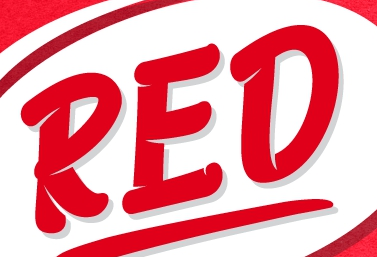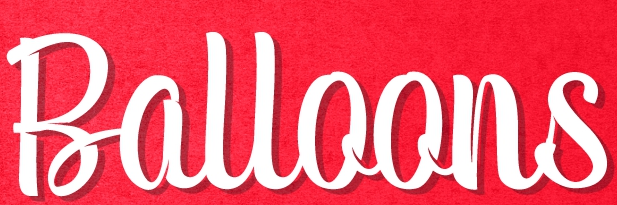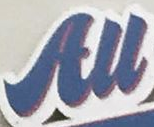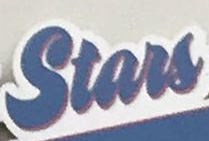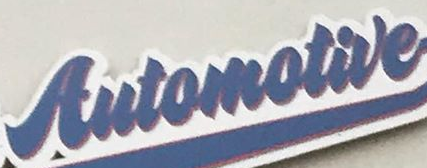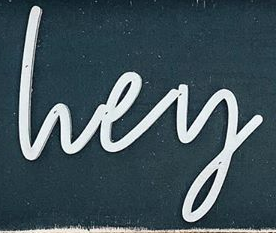Read the text content from these images in order, separated by a semicolon. RED; Balloons; All; Stars; Automotive; lvey 